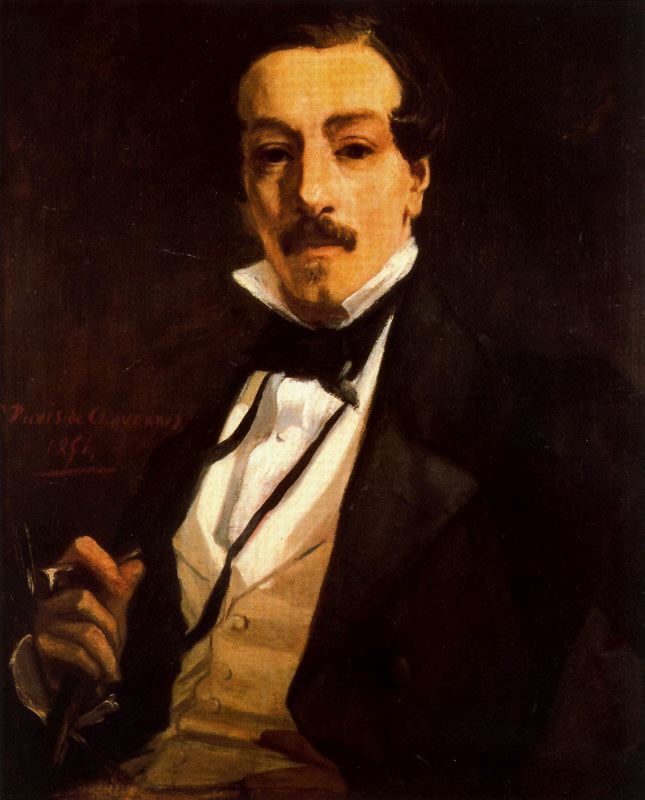Can you elaborate on the elements of the picture provided? The image displays a detailed portrait of a man, rendered in the impressionist style. The subject is dressed formally in a black suit jacket with satin lapels, paired with a white dress shirt, and a black bow tie neatly tied around the collar. Holding a pen delicately in his right hand as if interrupted during writing, the man gazes out from the painting, exuding an air of intellectual introspection. The dark, earthy tones that dominate the background, primarily deep browns and blacks, serve to highlight the brightness of his attire, creating a striking contrast and imbuing the scene with a sense of solemnity and depth. Adding to the authenticity of the piece, the artist's signature 'Pavlosk Ovsannikov 18..' is subtly inscribed in the lower left corner, perhaps dating it to the late 19th century. 